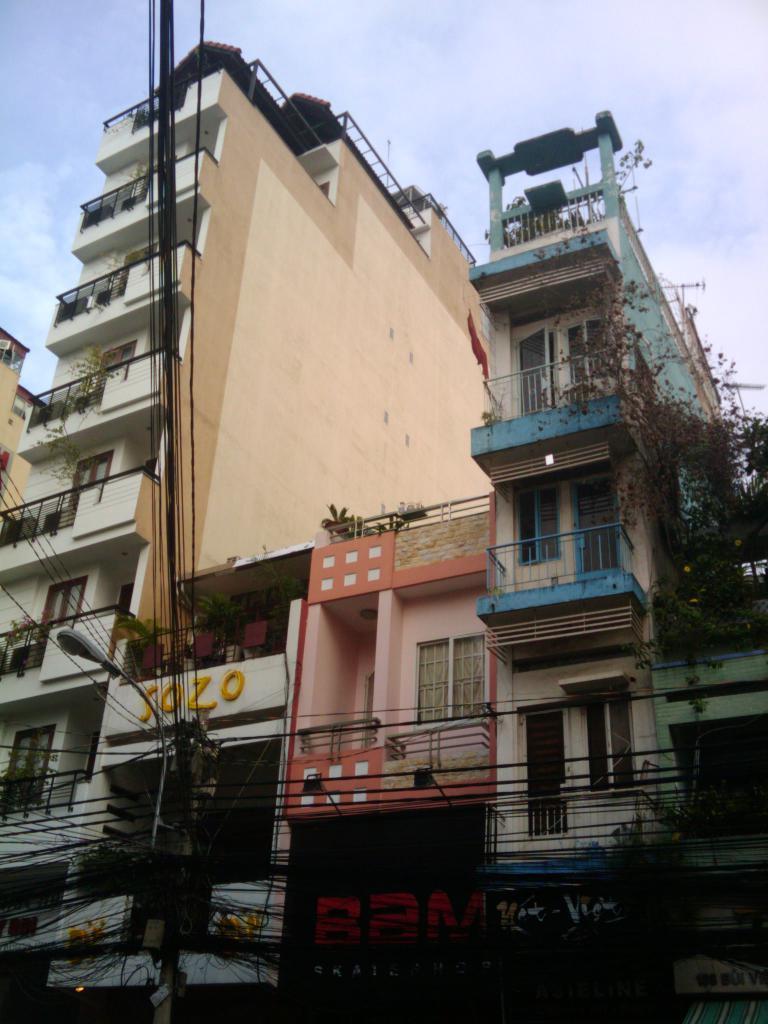Could you give a brief overview of what you see in this image? In the image there are apartments and buildings, in front of the buildings there are a lot of wires. 